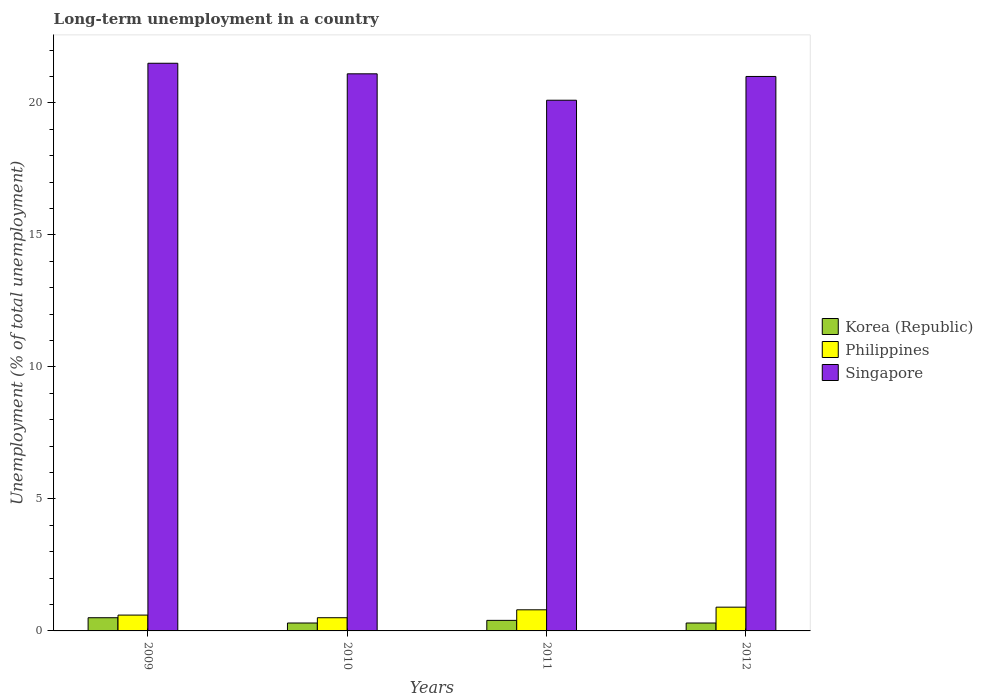How many different coloured bars are there?
Offer a terse response. 3. How many groups of bars are there?
Your answer should be compact. 4. Are the number of bars on each tick of the X-axis equal?
Offer a terse response. Yes. How many bars are there on the 1st tick from the right?
Ensure brevity in your answer.  3. In how many cases, is the number of bars for a given year not equal to the number of legend labels?
Offer a very short reply. 0. What is the percentage of long-term unemployed population in Singapore in 2009?
Your response must be concise. 21.5. Across all years, what is the maximum percentage of long-term unemployed population in Philippines?
Offer a very short reply. 0.9. Across all years, what is the minimum percentage of long-term unemployed population in Philippines?
Provide a short and direct response. 0.5. In which year was the percentage of long-term unemployed population in Philippines minimum?
Offer a very short reply. 2010. What is the total percentage of long-term unemployed population in Korea (Republic) in the graph?
Your answer should be very brief. 1.5. What is the difference between the percentage of long-term unemployed population in Korea (Republic) in 2011 and the percentage of long-term unemployed population in Singapore in 2010?
Give a very brief answer. -20.7. What is the average percentage of long-term unemployed population in Philippines per year?
Make the answer very short. 0.7. What is the ratio of the percentage of long-term unemployed population in Philippines in 2009 to that in 2011?
Give a very brief answer. 0.75. Is the percentage of long-term unemployed population in Philippines in 2011 less than that in 2012?
Offer a terse response. Yes. What is the difference between the highest and the second highest percentage of long-term unemployed population in Korea (Republic)?
Provide a succinct answer. 0.1. What is the difference between the highest and the lowest percentage of long-term unemployed population in Singapore?
Ensure brevity in your answer.  1.4. What does the 3rd bar from the left in 2012 represents?
Provide a short and direct response. Singapore. What does the 2nd bar from the right in 2012 represents?
Your response must be concise. Philippines. Is it the case that in every year, the sum of the percentage of long-term unemployed population in Singapore and percentage of long-term unemployed population in Korea (Republic) is greater than the percentage of long-term unemployed population in Philippines?
Give a very brief answer. Yes. How many bars are there?
Your response must be concise. 12. What is the difference between two consecutive major ticks on the Y-axis?
Keep it short and to the point. 5. Are the values on the major ticks of Y-axis written in scientific E-notation?
Your answer should be very brief. No. Does the graph contain grids?
Offer a terse response. No. How many legend labels are there?
Offer a very short reply. 3. What is the title of the graph?
Your answer should be compact. Long-term unemployment in a country. Does "Kazakhstan" appear as one of the legend labels in the graph?
Offer a terse response. No. What is the label or title of the Y-axis?
Ensure brevity in your answer.  Unemployment (% of total unemployment). What is the Unemployment (% of total unemployment) of Korea (Republic) in 2009?
Your answer should be compact. 0.5. What is the Unemployment (% of total unemployment) in Philippines in 2009?
Offer a very short reply. 0.6. What is the Unemployment (% of total unemployment) in Korea (Republic) in 2010?
Provide a succinct answer. 0.3. What is the Unemployment (% of total unemployment) of Philippines in 2010?
Provide a short and direct response. 0.5. What is the Unemployment (% of total unemployment) of Singapore in 2010?
Offer a terse response. 21.1. What is the Unemployment (% of total unemployment) of Korea (Republic) in 2011?
Offer a terse response. 0.4. What is the Unemployment (% of total unemployment) of Philippines in 2011?
Your answer should be very brief. 0.8. What is the Unemployment (% of total unemployment) of Singapore in 2011?
Ensure brevity in your answer.  20.1. What is the Unemployment (% of total unemployment) of Korea (Republic) in 2012?
Your answer should be compact. 0.3. What is the Unemployment (% of total unemployment) in Philippines in 2012?
Keep it short and to the point. 0.9. Across all years, what is the maximum Unemployment (% of total unemployment) of Philippines?
Give a very brief answer. 0.9. Across all years, what is the maximum Unemployment (% of total unemployment) of Singapore?
Your answer should be compact. 21.5. Across all years, what is the minimum Unemployment (% of total unemployment) in Korea (Republic)?
Your answer should be compact. 0.3. Across all years, what is the minimum Unemployment (% of total unemployment) in Philippines?
Your answer should be compact. 0.5. Across all years, what is the minimum Unemployment (% of total unemployment) in Singapore?
Offer a terse response. 20.1. What is the total Unemployment (% of total unemployment) of Korea (Republic) in the graph?
Provide a short and direct response. 1.5. What is the total Unemployment (% of total unemployment) in Philippines in the graph?
Your response must be concise. 2.8. What is the total Unemployment (% of total unemployment) of Singapore in the graph?
Your answer should be very brief. 83.7. What is the difference between the Unemployment (% of total unemployment) in Singapore in 2009 and that in 2010?
Offer a very short reply. 0.4. What is the difference between the Unemployment (% of total unemployment) in Korea (Republic) in 2009 and that in 2011?
Make the answer very short. 0.1. What is the difference between the Unemployment (% of total unemployment) in Singapore in 2009 and that in 2011?
Provide a short and direct response. 1.4. What is the difference between the Unemployment (% of total unemployment) in Singapore in 2009 and that in 2012?
Your response must be concise. 0.5. What is the difference between the Unemployment (% of total unemployment) in Philippines in 2010 and that in 2012?
Your response must be concise. -0.4. What is the difference between the Unemployment (% of total unemployment) in Philippines in 2011 and that in 2012?
Give a very brief answer. -0.1. What is the difference between the Unemployment (% of total unemployment) of Singapore in 2011 and that in 2012?
Keep it short and to the point. -0.9. What is the difference between the Unemployment (% of total unemployment) of Korea (Republic) in 2009 and the Unemployment (% of total unemployment) of Philippines in 2010?
Provide a short and direct response. 0. What is the difference between the Unemployment (% of total unemployment) of Korea (Republic) in 2009 and the Unemployment (% of total unemployment) of Singapore in 2010?
Keep it short and to the point. -20.6. What is the difference between the Unemployment (% of total unemployment) of Philippines in 2009 and the Unemployment (% of total unemployment) of Singapore in 2010?
Your answer should be very brief. -20.5. What is the difference between the Unemployment (% of total unemployment) of Korea (Republic) in 2009 and the Unemployment (% of total unemployment) of Singapore in 2011?
Provide a short and direct response. -19.6. What is the difference between the Unemployment (% of total unemployment) of Philippines in 2009 and the Unemployment (% of total unemployment) of Singapore in 2011?
Provide a succinct answer. -19.5. What is the difference between the Unemployment (% of total unemployment) of Korea (Republic) in 2009 and the Unemployment (% of total unemployment) of Philippines in 2012?
Offer a very short reply. -0.4. What is the difference between the Unemployment (% of total unemployment) in Korea (Republic) in 2009 and the Unemployment (% of total unemployment) in Singapore in 2012?
Ensure brevity in your answer.  -20.5. What is the difference between the Unemployment (% of total unemployment) of Philippines in 2009 and the Unemployment (% of total unemployment) of Singapore in 2012?
Ensure brevity in your answer.  -20.4. What is the difference between the Unemployment (% of total unemployment) in Korea (Republic) in 2010 and the Unemployment (% of total unemployment) in Philippines in 2011?
Your response must be concise. -0.5. What is the difference between the Unemployment (% of total unemployment) in Korea (Republic) in 2010 and the Unemployment (% of total unemployment) in Singapore in 2011?
Offer a very short reply. -19.8. What is the difference between the Unemployment (% of total unemployment) of Philippines in 2010 and the Unemployment (% of total unemployment) of Singapore in 2011?
Keep it short and to the point. -19.6. What is the difference between the Unemployment (% of total unemployment) of Korea (Republic) in 2010 and the Unemployment (% of total unemployment) of Singapore in 2012?
Your answer should be compact. -20.7. What is the difference between the Unemployment (% of total unemployment) in Philippines in 2010 and the Unemployment (% of total unemployment) in Singapore in 2012?
Offer a very short reply. -20.5. What is the difference between the Unemployment (% of total unemployment) in Korea (Republic) in 2011 and the Unemployment (% of total unemployment) in Philippines in 2012?
Provide a succinct answer. -0.5. What is the difference between the Unemployment (% of total unemployment) of Korea (Republic) in 2011 and the Unemployment (% of total unemployment) of Singapore in 2012?
Your response must be concise. -20.6. What is the difference between the Unemployment (% of total unemployment) of Philippines in 2011 and the Unemployment (% of total unemployment) of Singapore in 2012?
Your answer should be compact. -20.2. What is the average Unemployment (% of total unemployment) of Philippines per year?
Your answer should be very brief. 0.7. What is the average Unemployment (% of total unemployment) in Singapore per year?
Your response must be concise. 20.93. In the year 2009, what is the difference between the Unemployment (% of total unemployment) of Philippines and Unemployment (% of total unemployment) of Singapore?
Offer a very short reply. -20.9. In the year 2010, what is the difference between the Unemployment (% of total unemployment) of Korea (Republic) and Unemployment (% of total unemployment) of Philippines?
Make the answer very short. -0.2. In the year 2010, what is the difference between the Unemployment (% of total unemployment) in Korea (Republic) and Unemployment (% of total unemployment) in Singapore?
Make the answer very short. -20.8. In the year 2010, what is the difference between the Unemployment (% of total unemployment) in Philippines and Unemployment (% of total unemployment) in Singapore?
Keep it short and to the point. -20.6. In the year 2011, what is the difference between the Unemployment (% of total unemployment) of Korea (Republic) and Unemployment (% of total unemployment) of Singapore?
Keep it short and to the point. -19.7. In the year 2011, what is the difference between the Unemployment (% of total unemployment) of Philippines and Unemployment (% of total unemployment) of Singapore?
Your answer should be very brief. -19.3. In the year 2012, what is the difference between the Unemployment (% of total unemployment) of Korea (Republic) and Unemployment (% of total unemployment) of Singapore?
Your answer should be compact. -20.7. In the year 2012, what is the difference between the Unemployment (% of total unemployment) in Philippines and Unemployment (% of total unemployment) in Singapore?
Your answer should be very brief. -20.1. What is the ratio of the Unemployment (% of total unemployment) in Singapore in 2009 to that in 2010?
Provide a short and direct response. 1.02. What is the ratio of the Unemployment (% of total unemployment) in Philippines in 2009 to that in 2011?
Keep it short and to the point. 0.75. What is the ratio of the Unemployment (% of total unemployment) of Singapore in 2009 to that in 2011?
Give a very brief answer. 1.07. What is the ratio of the Unemployment (% of total unemployment) in Philippines in 2009 to that in 2012?
Provide a succinct answer. 0.67. What is the ratio of the Unemployment (% of total unemployment) in Singapore in 2009 to that in 2012?
Keep it short and to the point. 1.02. What is the ratio of the Unemployment (% of total unemployment) in Korea (Republic) in 2010 to that in 2011?
Keep it short and to the point. 0.75. What is the ratio of the Unemployment (% of total unemployment) in Singapore in 2010 to that in 2011?
Your answer should be compact. 1.05. What is the ratio of the Unemployment (% of total unemployment) in Philippines in 2010 to that in 2012?
Provide a short and direct response. 0.56. What is the ratio of the Unemployment (% of total unemployment) of Korea (Republic) in 2011 to that in 2012?
Give a very brief answer. 1.33. What is the ratio of the Unemployment (% of total unemployment) of Philippines in 2011 to that in 2012?
Provide a short and direct response. 0.89. What is the ratio of the Unemployment (% of total unemployment) of Singapore in 2011 to that in 2012?
Your response must be concise. 0.96. What is the difference between the highest and the second highest Unemployment (% of total unemployment) in Korea (Republic)?
Give a very brief answer. 0.1. What is the difference between the highest and the lowest Unemployment (% of total unemployment) in Korea (Republic)?
Offer a terse response. 0.2. 